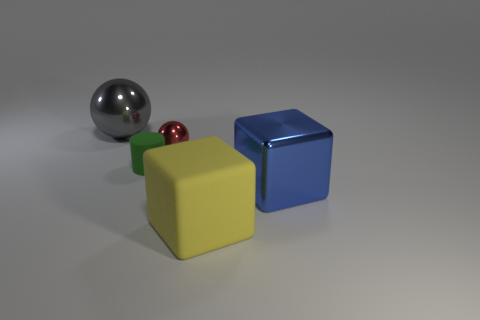What number of big things are shiny objects or cubes?
Make the answer very short. 3. Is there any other thing that is the same color as the small cylinder?
Your answer should be very brief. No. Does the block on the left side of the shiny cube have the same size as the gray metal sphere?
Your answer should be compact. Yes. What is the color of the sphere left of the rubber object behind the rubber thing that is right of the tiny green cylinder?
Your response must be concise. Gray. The tiny sphere has what color?
Your answer should be very brief. Red. Is the color of the tiny metal object the same as the tiny cylinder?
Make the answer very short. No. Do the big thing that is in front of the blue metal object and the big thing that is on the left side of the small red object have the same material?
Keep it short and to the point. No. There is a large gray object that is the same shape as the small metal object; what material is it?
Your answer should be very brief. Metal. Do the small green cylinder and the yellow object have the same material?
Your answer should be compact. Yes. What is the color of the big block to the left of the cube that is right of the rubber cube?
Your answer should be compact. Yellow. 